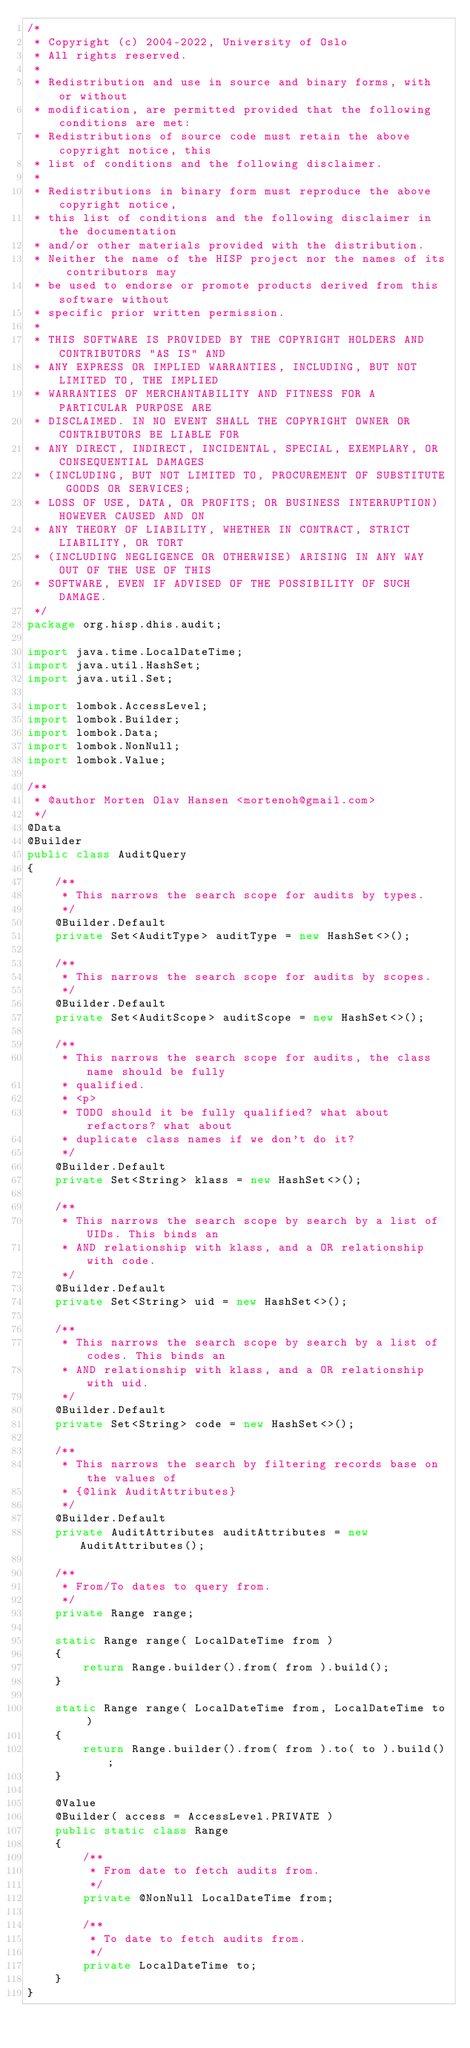<code> <loc_0><loc_0><loc_500><loc_500><_Java_>/*
 * Copyright (c) 2004-2022, University of Oslo
 * All rights reserved.
 *
 * Redistribution and use in source and binary forms, with or without
 * modification, are permitted provided that the following conditions are met:
 * Redistributions of source code must retain the above copyright notice, this
 * list of conditions and the following disclaimer.
 *
 * Redistributions in binary form must reproduce the above copyright notice,
 * this list of conditions and the following disclaimer in the documentation
 * and/or other materials provided with the distribution.
 * Neither the name of the HISP project nor the names of its contributors may
 * be used to endorse or promote products derived from this software without
 * specific prior written permission.
 *
 * THIS SOFTWARE IS PROVIDED BY THE COPYRIGHT HOLDERS AND CONTRIBUTORS "AS IS" AND
 * ANY EXPRESS OR IMPLIED WARRANTIES, INCLUDING, BUT NOT LIMITED TO, THE IMPLIED
 * WARRANTIES OF MERCHANTABILITY AND FITNESS FOR A PARTICULAR PURPOSE ARE
 * DISCLAIMED. IN NO EVENT SHALL THE COPYRIGHT OWNER OR CONTRIBUTORS BE LIABLE FOR
 * ANY DIRECT, INDIRECT, INCIDENTAL, SPECIAL, EXEMPLARY, OR CONSEQUENTIAL DAMAGES
 * (INCLUDING, BUT NOT LIMITED TO, PROCUREMENT OF SUBSTITUTE GOODS OR SERVICES;
 * LOSS OF USE, DATA, OR PROFITS; OR BUSINESS INTERRUPTION) HOWEVER CAUSED AND ON
 * ANY THEORY OF LIABILITY, WHETHER IN CONTRACT, STRICT LIABILITY, OR TORT
 * (INCLUDING NEGLIGENCE OR OTHERWISE) ARISING IN ANY WAY OUT OF THE USE OF THIS
 * SOFTWARE, EVEN IF ADVISED OF THE POSSIBILITY OF SUCH DAMAGE.
 */
package org.hisp.dhis.audit;

import java.time.LocalDateTime;
import java.util.HashSet;
import java.util.Set;

import lombok.AccessLevel;
import lombok.Builder;
import lombok.Data;
import lombok.NonNull;
import lombok.Value;

/**
 * @author Morten Olav Hansen <mortenoh@gmail.com>
 */
@Data
@Builder
public class AuditQuery
{
    /**
     * This narrows the search scope for audits by types.
     */
    @Builder.Default
    private Set<AuditType> auditType = new HashSet<>();

    /**
     * This narrows the search scope for audits by scopes.
     */
    @Builder.Default
    private Set<AuditScope> auditScope = new HashSet<>();

    /**
     * This narrows the search scope for audits, the class name should be fully
     * qualified.
     * <p>
     * TODO should it be fully qualified? what about refactors? what about
     * duplicate class names if we don't do it?
     */
    @Builder.Default
    private Set<String> klass = new HashSet<>();

    /**
     * This narrows the search scope by search by a list of UIDs. This binds an
     * AND relationship with klass, and a OR relationship with code.
     */
    @Builder.Default
    private Set<String> uid = new HashSet<>();

    /**
     * This narrows the search scope by search by a list of codes. This binds an
     * AND relationship with klass, and a OR relationship with uid.
     */
    @Builder.Default
    private Set<String> code = new HashSet<>();

    /**
     * This narrows the search by filtering records base on the values of
     * {@link AuditAttributes}
     */
    @Builder.Default
    private AuditAttributes auditAttributes = new AuditAttributes();

    /**
     * From/To dates to query from.
     */
    private Range range;

    static Range range( LocalDateTime from )
    {
        return Range.builder().from( from ).build();
    }

    static Range range( LocalDateTime from, LocalDateTime to )
    {
        return Range.builder().from( from ).to( to ).build();
    }

    @Value
    @Builder( access = AccessLevel.PRIVATE )
    public static class Range
    {
        /**
         * From date to fetch audits from.
         */
        private @NonNull LocalDateTime from;

        /**
         * To date to fetch audits from.
         */
        private LocalDateTime to;
    }
}
</code> 